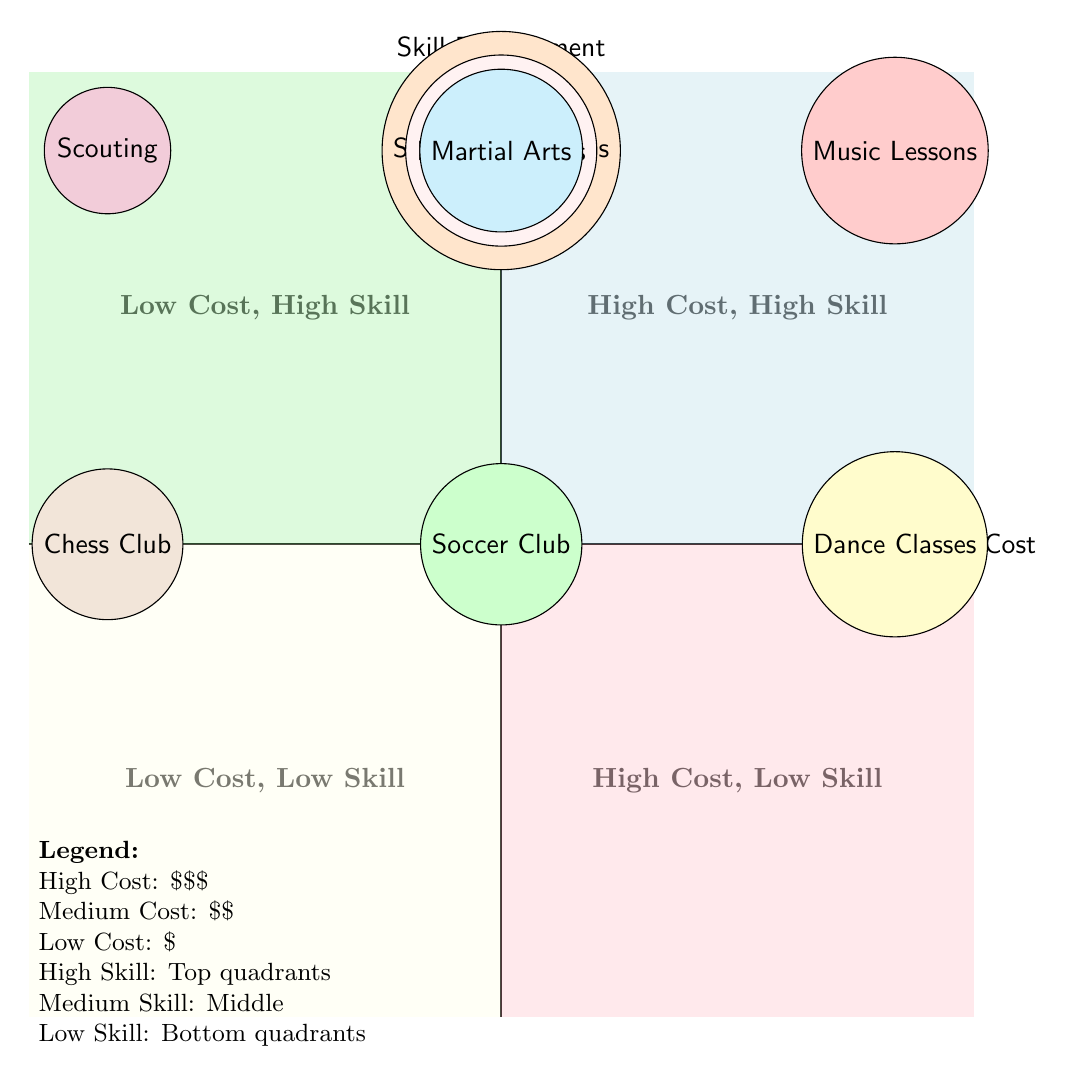What is the activity with the highest skill development? The activity with the highest skill development in the diagram is "Music Lessons," which is located in the high-cost, high-skill quadrant.
Answer: Music Lessons Which activity has a low cost and low skill development? The quadrant representing low cost and low skill development contains the "Soccer Club," which indicates it has a combination of low cost and medium skill development, but there are no activities in the low skill development segment (the bottom left quadrant).
Answer: None How many activities are classified as high cost? By counting the number of activities located in the top right quadrant, which categorizes them as high cost and high skill, we identify that there are two: "Music Lessons" and "Dance Classes."
Answer: Two What is the skill development level of the "Scouting" activity? Since "Scouting" is located in the low cost, high skill quadrant, it signifies a high level of skill development.
Answer: High Which activity has a medium cost and is in the high skill quadrant? The activities found in the high skill quadrant with a medium cost are "Art Classes," "Swimming Lessons," "Drama Classes," and "Martial Arts." They are all centered in the top middle section of the chart.
Answer: Art Classes, Swimming Lessons, Drama Classes, Martial Arts What is the relationship between "Chess Club" and "Soccer Club"? "Chess Club" falls into the low cost, medium skill quadrant, whereas "Soccer Club" is in the low cost, low skill quadrant; thus, they share the low cost characteristic but differ in skill development.
Answer: Both share low cost; differ in skill development 